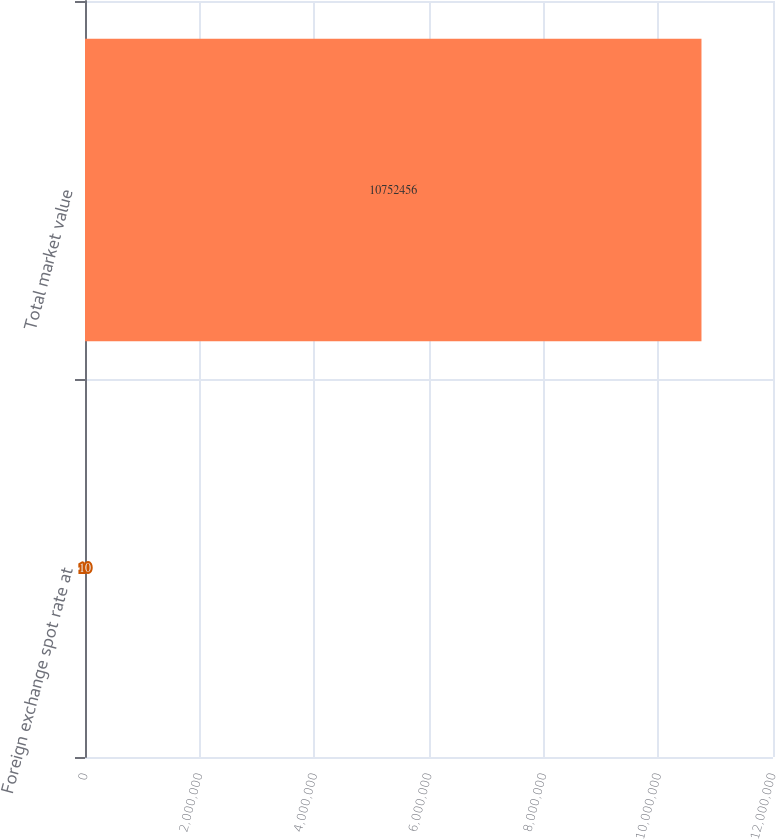<chart> <loc_0><loc_0><loc_500><loc_500><bar_chart><fcel>Foreign exchange spot rate at<fcel>Total market value<nl><fcel>10<fcel>1.07525e+07<nl></chart> 